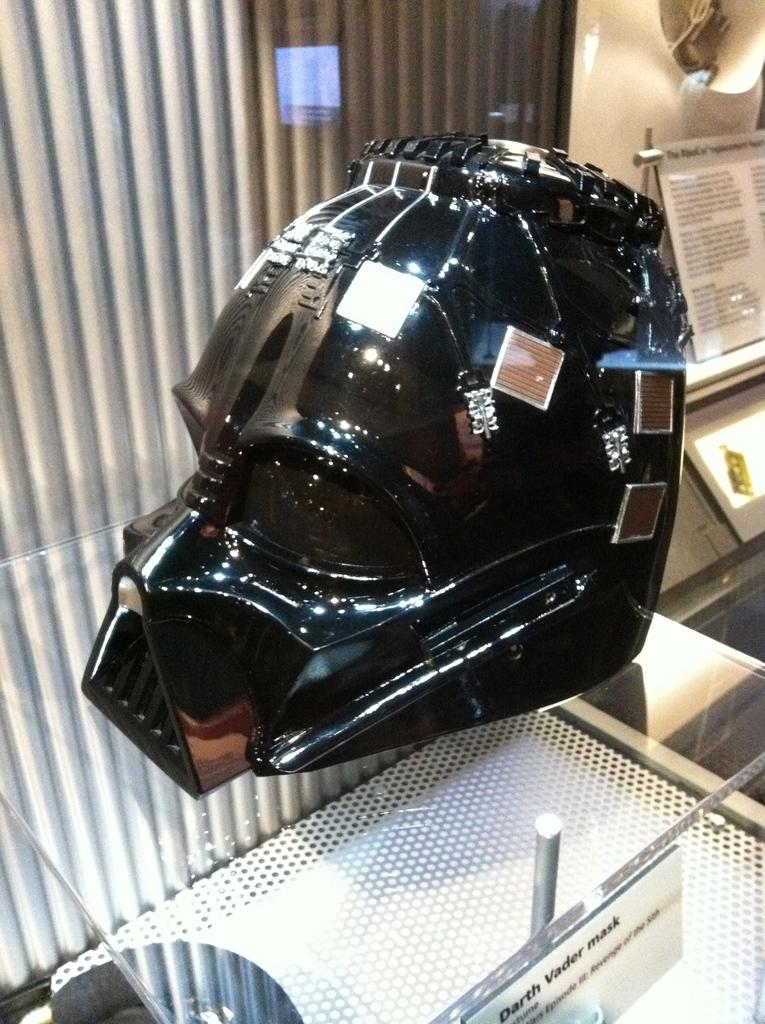What is the color of the object on the glass? The object on the glass is black. What is the object placed on? The object is placed on a glass. Is there any additional information provided about the object or the glass? Yes, there is a note at the back. What is the income of the person who owns the glass in the image? There is no information about the person's income in the image. What type of drink is in the glass? The image does not show any drink in the glass, only a black object. 